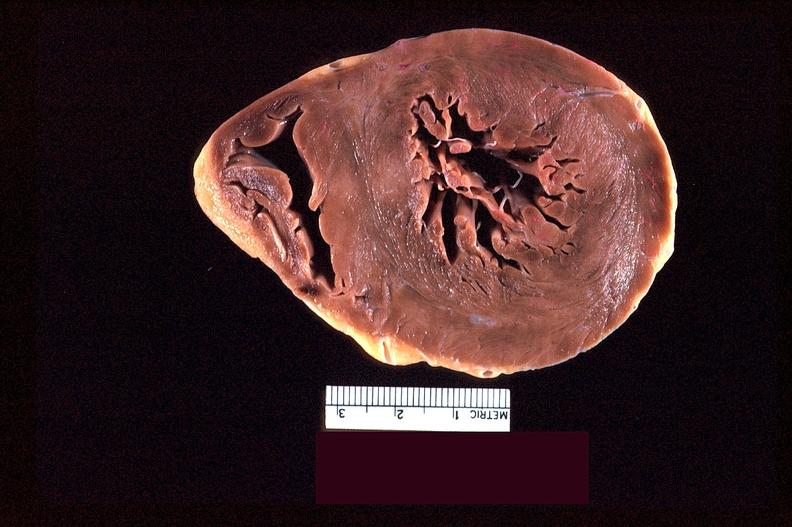what is present?
Answer the question using a single word or phrase. Cardiovascular 